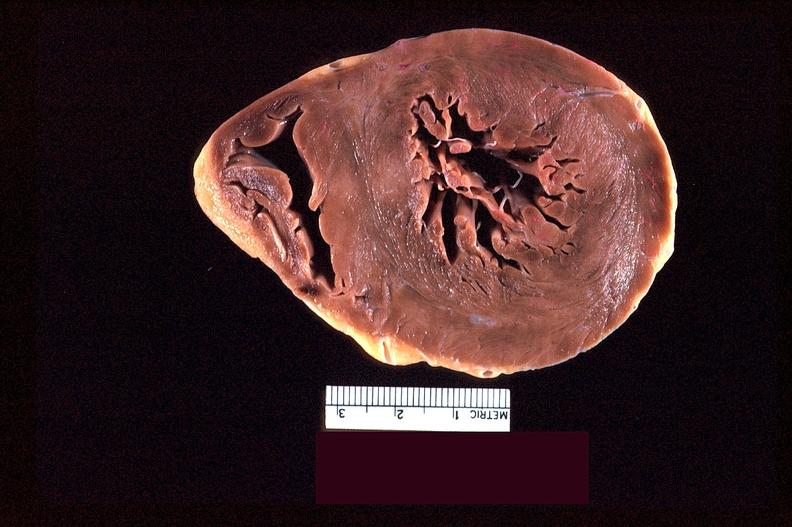what is present?
Answer the question using a single word or phrase. Cardiovascular 